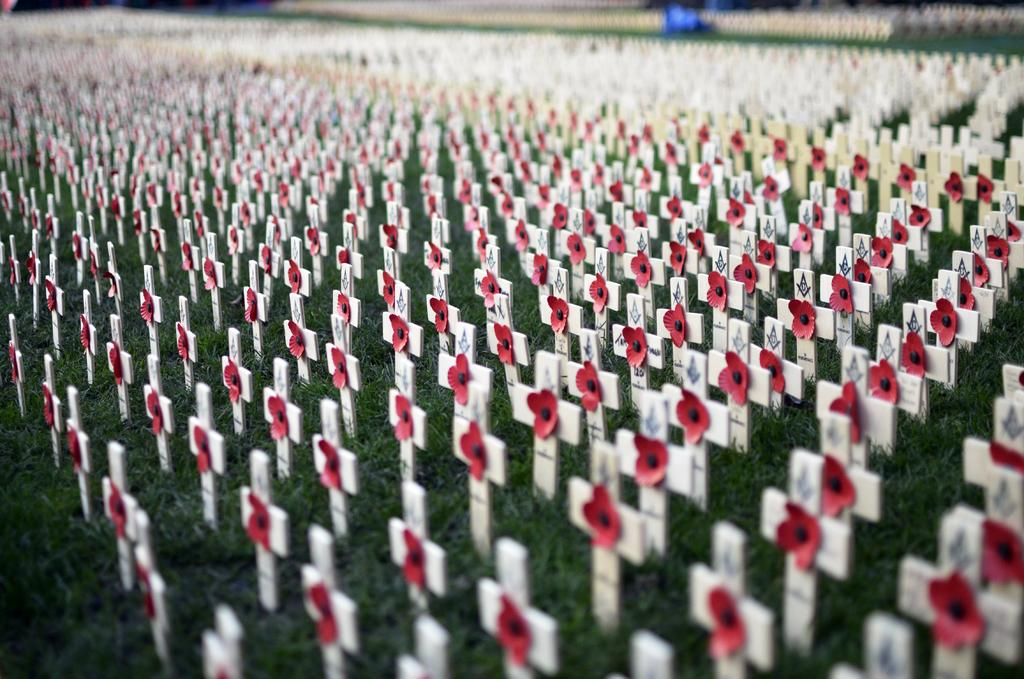What religious symbols can be seen in the image? There are holy cross symbols in the image. How are the holy cross symbols decorated? Flowers are attached to the holy cross symbols. Where are the holy cross symbols located? The holy cross symbols are on the grass. Can you describe the background of the image? The background of the image is blurred. What type of cake is being offered to the beggar in the image? There is no cake or beggar present in the image; it features holy cross symbols with flowers on the grass. 